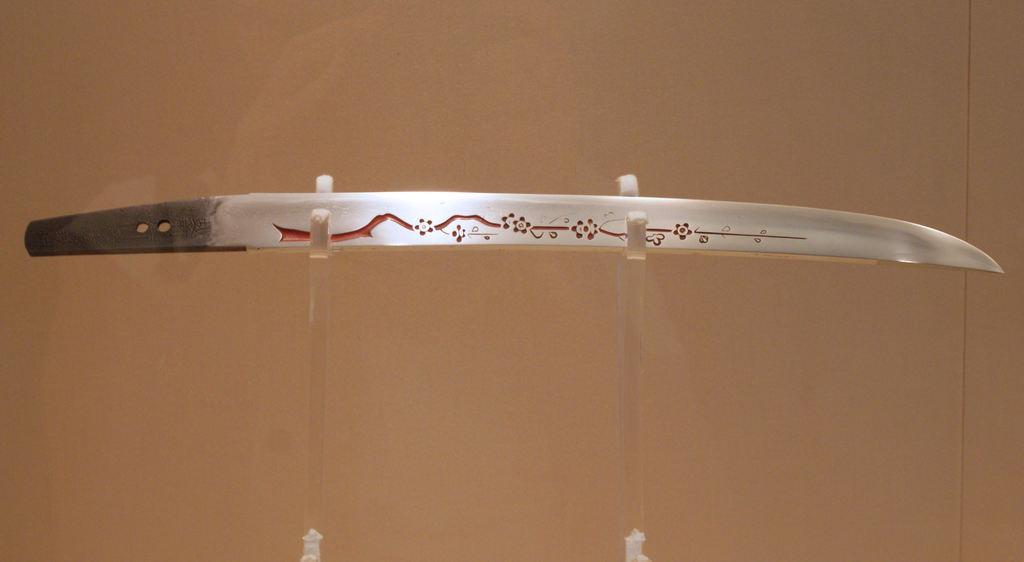Could you give a brief overview of what you see in this image? In this picture there is a sword in the center of the image. 